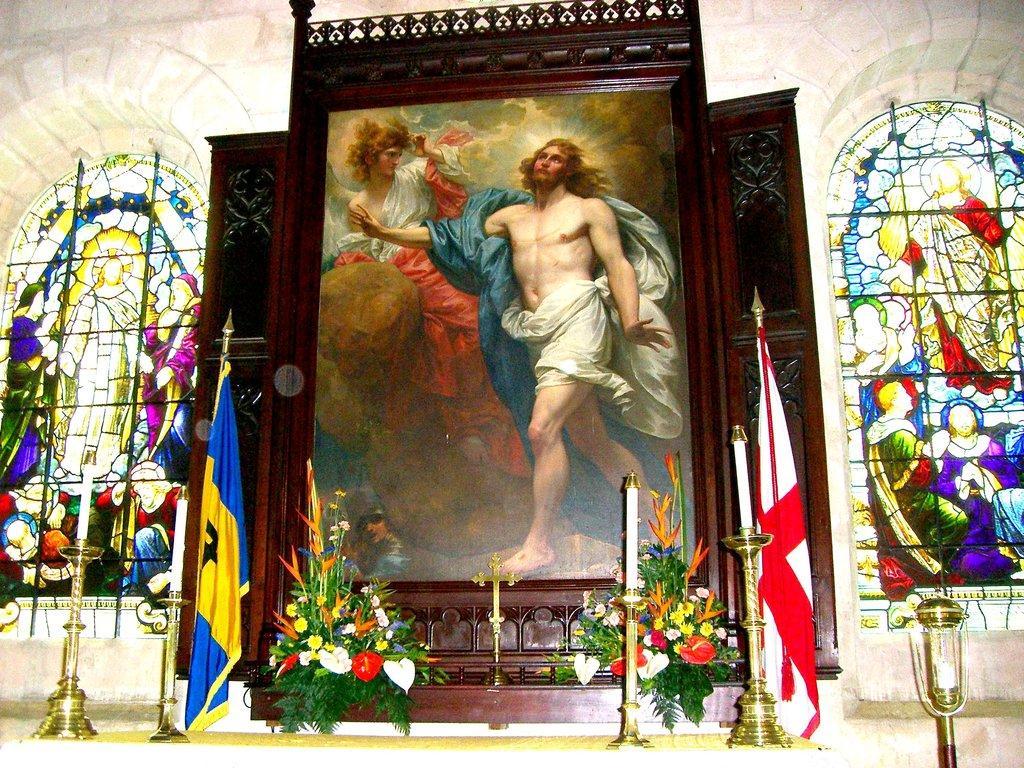Can you describe this image briefly? In this picture there are flags, candles and flower vases in the foreground and there is a painting of two people on the board and there are stained windows. At the bottom there is a floor. 